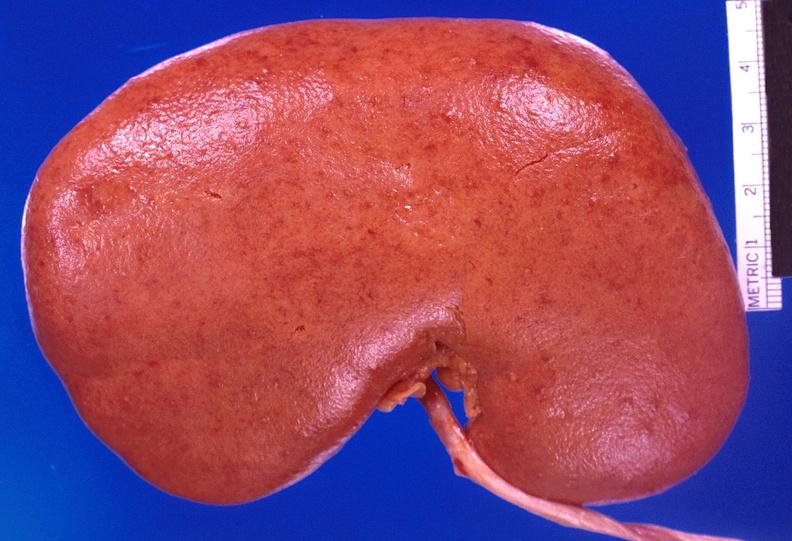what does this image show?
Answer the question using a single word or phrase. Kidney 